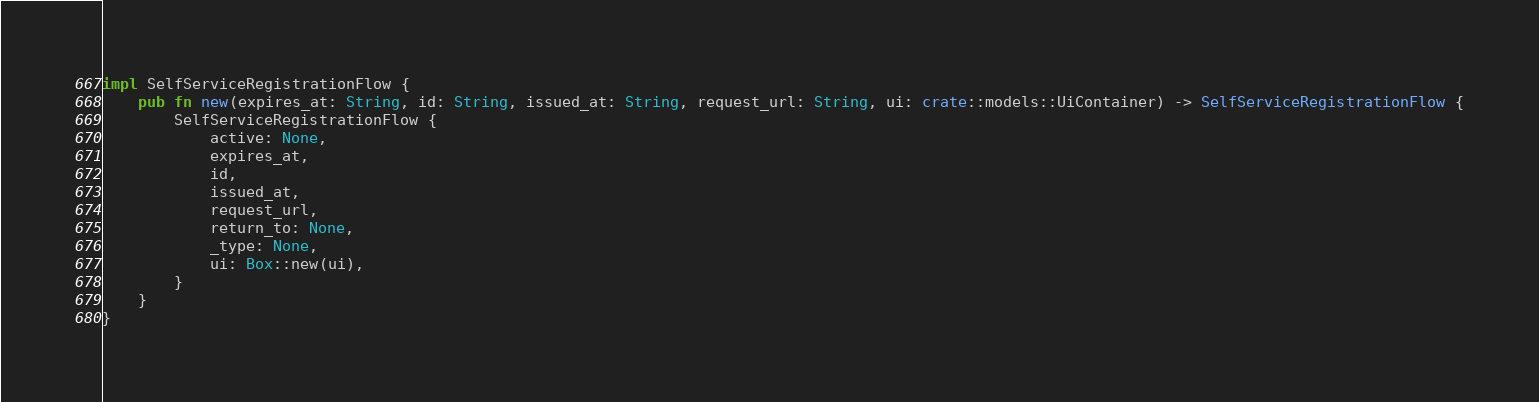<code> <loc_0><loc_0><loc_500><loc_500><_Rust_>
impl SelfServiceRegistrationFlow {
    pub fn new(expires_at: String, id: String, issued_at: String, request_url: String, ui: crate::models::UiContainer) -> SelfServiceRegistrationFlow {
        SelfServiceRegistrationFlow {
            active: None,
            expires_at,
            id,
            issued_at,
            request_url,
            return_to: None,
            _type: None,
            ui: Box::new(ui),
        }
    }
}


</code> 